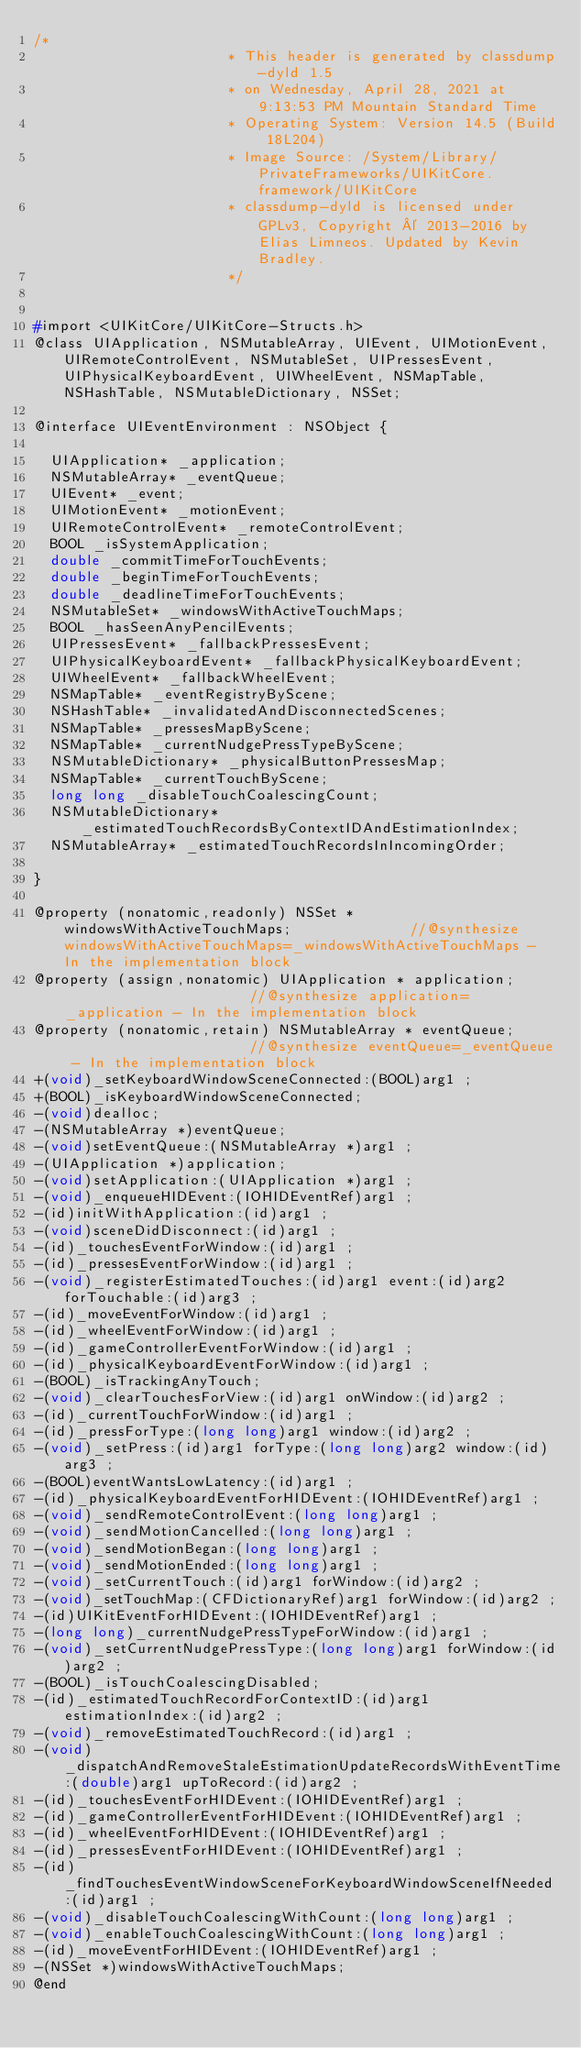<code> <loc_0><loc_0><loc_500><loc_500><_C_>/*
                       * This header is generated by classdump-dyld 1.5
                       * on Wednesday, April 28, 2021 at 9:13:53 PM Mountain Standard Time
                       * Operating System: Version 14.5 (Build 18L204)
                       * Image Source: /System/Library/PrivateFrameworks/UIKitCore.framework/UIKitCore
                       * classdump-dyld is licensed under GPLv3, Copyright © 2013-2016 by Elias Limneos. Updated by Kevin Bradley.
                       */


#import <UIKitCore/UIKitCore-Structs.h>
@class UIApplication, NSMutableArray, UIEvent, UIMotionEvent, UIRemoteControlEvent, NSMutableSet, UIPressesEvent, UIPhysicalKeyboardEvent, UIWheelEvent, NSMapTable, NSHashTable, NSMutableDictionary, NSSet;

@interface UIEventEnvironment : NSObject {

	UIApplication* _application;
	NSMutableArray* _eventQueue;
	UIEvent* _event;
	UIMotionEvent* _motionEvent;
	UIRemoteControlEvent* _remoteControlEvent;
	BOOL _isSystemApplication;
	double _commitTimeForTouchEvents;
	double _beginTimeForTouchEvents;
	double _deadlineTimeForTouchEvents;
	NSMutableSet* _windowsWithActiveTouchMaps;
	BOOL _hasSeenAnyPencilEvents;
	UIPressesEvent* _fallbackPressesEvent;
	UIPhysicalKeyboardEvent* _fallbackPhysicalKeyboardEvent;
	UIWheelEvent* _fallbackWheelEvent;
	NSMapTable* _eventRegistryByScene;
	NSHashTable* _invalidatedAndDisconnectedScenes;
	NSMapTable* _pressesMapByScene;
	NSMapTable* _currentNudgePressTypeByScene;
	NSMutableDictionary* _physicalButtonPressesMap;
	NSMapTable* _currentTouchByScene;
	long long _disableTouchCoalescingCount;
	NSMutableDictionary* _estimatedTouchRecordsByContextIDAndEstimationIndex;
	NSMutableArray* _estimatedTouchRecordsInIncomingOrder;

}

@property (nonatomic,readonly) NSSet * windowsWithActiveTouchMaps;              //@synthesize windowsWithActiveTouchMaps=_windowsWithActiveTouchMaps - In the implementation block
@property (assign,nonatomic) UIApplication * application;                       //@synthesize application=_application - In the implementation block
@property (nonatomic,retain) NSMutableArray * eventQueue;                       //@synthesize eventQueue=_eventQueue - In the implementation block
+(void)_setKeyboardWindowSceneConnected:(BOOL)arg1 ;
+(BOOL)_isKeyboardWindowSceneConnected;
-(void)dealloc;
-(NSMutableArray *)eventQueue;
-(void)setEventQueue:(NSMutableArray *)arg1 ;
-(UIApplication *)application;
-(void)setApplication:(UIApplication *)arg1 ;
-(void)_enqueueHIDEvent:(IOHIDEventRef)arg1 ;
-(id)initWithApplication:(id)arg1 ;
-(void)sceneDidDisconnect:(id)arg1 ;
-(id)_touchesEventForWindow:(id)arg1 ;
-(id)_pressesEventForWindow:(id)arg1 ;
-(void)_registerEstimatedTouches:(id)arg1 event:(id)arg2 forTouchable:(id)arg3 ;
-(id)_moveEventForWindow:(id)arg1 ;
-(id)_wheelEventForWindow:(id)arg1 ;
-(id)_gameControllerEventForWindow:(id)arg1 ;
-(id)_physicalKeyboardEventForWindow:(id)arg1 ;
-(BOOL)_isTrackingAnyTouch;
-(void)_clearTouchesForView:(id)arg1 onWindow:(id)arg2 ;
-(id)_currentTouchForWindow:(id)arg1 ;
-(id)_pressForType:(long long)arg1 window:(id)arg2 ;
-(void)_setPress:(id)arg1 forType:(long long)arg2 window:(id)arg3 ;
-(BOOL)eventWantsLowLatency:(id)arg1 ;
-(id)_physicalKeyboardEventForHIDEvent:(IOHIDEventRef)arg1 ;
-(void)_sendRemoteControlEvent:(long long)arg1 ;
-(void)_sendMotionCancelled:(long long)arg1 ;
-(void)_sendMotionBegan:(long long)arg1 ;
-(void)_sendMotionEnded:(long long)arg1 ;
-(void)_setCurrentTouch:(id)arg1 forWindow:(id)arg2 ;
-(void)_setTouchMap:(CFDictionaryRef)arg1 forWindow:(id)arg2 ;
-(id)UIKitEventForHIDEvent:(IOHIDEventRef)arg1 ;
-(long long)_currentNudgePressTypeForWindow:(id)arg1 ;
-(void)_setCurrentNudgePressType:(long long)arg1 forWindow:(id)arg2 ;
-(BOOL)_isTouchCoalescingDisabled;
-(id)_estimatedTouchRecordForContextID:(id)arg1 estimationIndex:(id)arg2 ;
-(void)_removeEstimatedTouchRecord:(id)arg1 ;
-(void)_dispatchAndRemoveStaleEstimationUpdateRecordsWithEventTime:(double)arg1 upToRecord:(id)arg2 ;
-(id)_touchesEventForHIDEvent:(IOHIDEventRef)arg1 ;
-(id)_gameControllerEventForHIDEvent:(IOHIDEventRef)arg1 ;
-(id)_wheelEventForHIDEvent:(IOHIDEventRef)arg1 ;
-(id)_pressesEventForHIDEvent:(IOHIDEventRef)arg1 ;
-(id)_findTouchesEventWindowSceneForKeyboardWindowSceneIfNeeded:(id)arg1 ;
-(void)_disableTouchCoalescingWithCount:(long long)arg1 ;
-(void)_enableTouchCoalescingWithCount:(long long)arg1 ;
-(id)_moveEventForHIDEvent:(IOHIDEventRef)arg1 ;
-(NSSet *)windowsWithActiveTouchMaps;
@end

</code> 